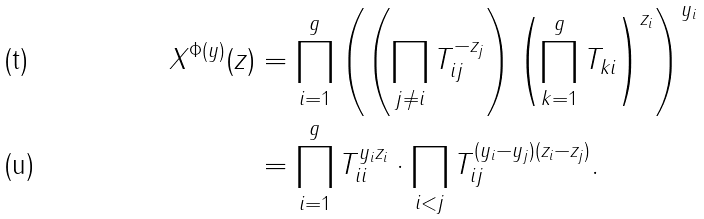<formula> <loc_0><loc_0><loc_500><loc_500>X ^ { \Phi ( y ) } ( z ) & = \prod _ { i = 1 } ^ { g } \left ( \left ( \prod _ { j \neq i } T _ { i j } ^ { - z _ { j } } \right ) \left ( \prod _ { k = 1 } ^ { g } T _ { k i } \right ) ^ { z _ { i } } \right ) ^ { y _ { i } } \\ & = \prod _ { i = 1 } ^ { g } T _ { i i } ^ { y _ { i } z _ { i } } \cdot \prod _ { i < j } T _ { i j } ^ { ( y _ { i } - y _ { j } ) ( z _ { i } - z _ { j } ) } .</formula> 